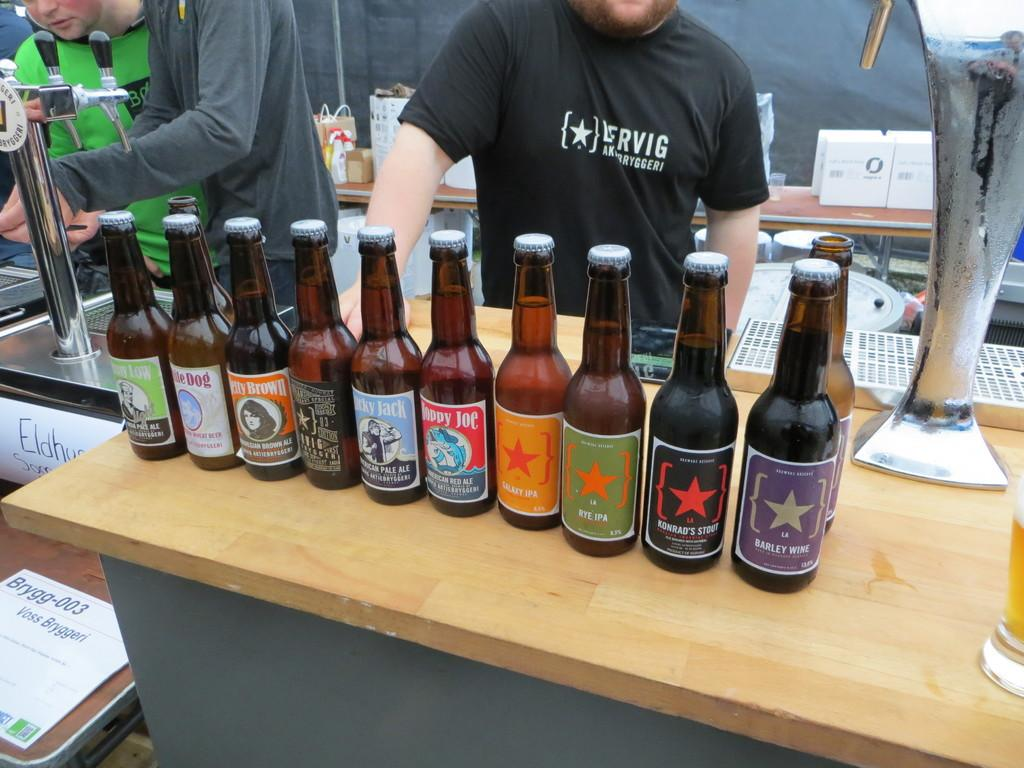<image>
Render a clear and concise summary of the photo. A bottle of Barley Wine with a purple label 